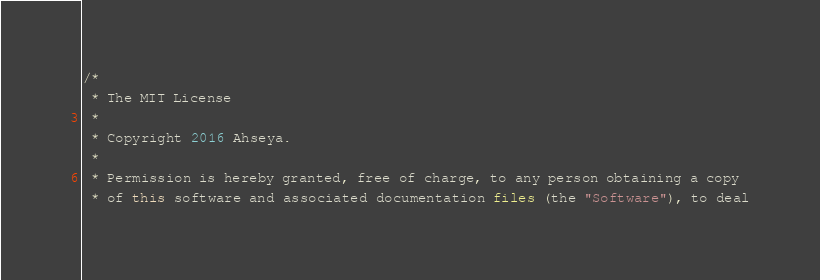Convert code to text. <code><loc_0><loc_0><loc_500><loc_500><_Java_>/*
 * The MIT License
 *
 * Copyright 2016 Ahseya.
 *
 * Permission is hereby granted, free of charge, to any person obtaining a copy
 * of this software and associated documentation files (the "Software"), to deal</code> 